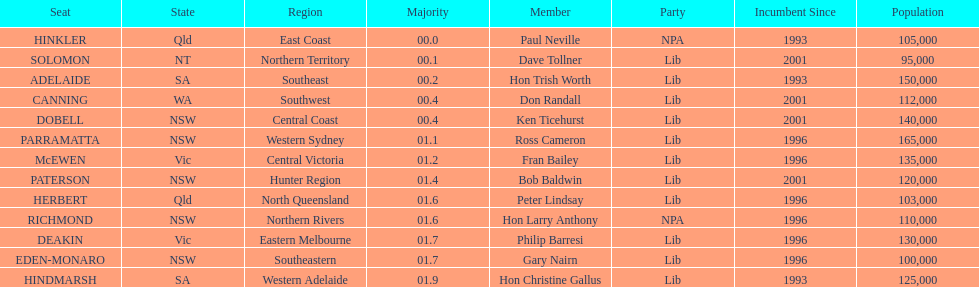Tell me the number of seats from nsw? 5. Would you be able to parse every entry in this table? {'header': ['Seat', 'State', 'Region', 'Majority', 'Member', 'Party', 'Incumbent Since', 'Population'], 'rows': [['HINKLER', 'Qld', 'East Coast', '00.0', 'Paul Neville', 'NPA', '1993', '105,000'], ['SOLOMON', 'NT', 'Northern Territory', '00.1', 'Dave Tollner', 'Lib', '2001', '95,000'], ['ADELAIDE', 'SA', 'Southeast', '00.2', 'Hon Trish Worth', 'Lib', '1993', '150,000'], ['CANNING', 'WA', 'Southwest', '00.4', 'Don Randall', 'Lib', '2001', '112,000'], ['DOBELL', 'NSW', 'Central Coast', '00.4', 'Ken Ticehurst', 'Lib', '2001', '140,000'], ['PARRAMATTA', 'NSW', 'Western Sydney', '01.1', 'Ross Cameron', 'Lib', '1996', '165,000'], ['McEWEN', 'Vic', 'Central Victoria', '01.2', 'Fran Bailey', 'Lib', '1996', '135,000'], ['PATERSON', 'NSW', 'Hunter Region', '01.4', 'Bob Baldwin', 'Lib', '2001', '120,000'], ['HERBERT', 'Qld', 'North Queensland', '01.6', 'Peter Lindsay', 'Lib', '1996', '103,000'], ['RICHMOND', 'NSW', 'Northern Rivers', '01.6', 'Hon Larry Anthony', 'NPA', '1996', '110,000'], ['DEAKIN', 'Vic', 'Eastern Melbourne', '01.7', 'Philip Barresi', 'Lib', '1996', '130,000'], ['EDEN-MONARO', 'NSW', 'Southeastern', '01.7', 'Gary Nairn', 'Lib', '1996', '100,000'], ['HINDMARSH', 'SA', 'Western Adelaide', '01.9', 'Hon Christine Gallus', 'Lib', '1993', '125,000']]} 